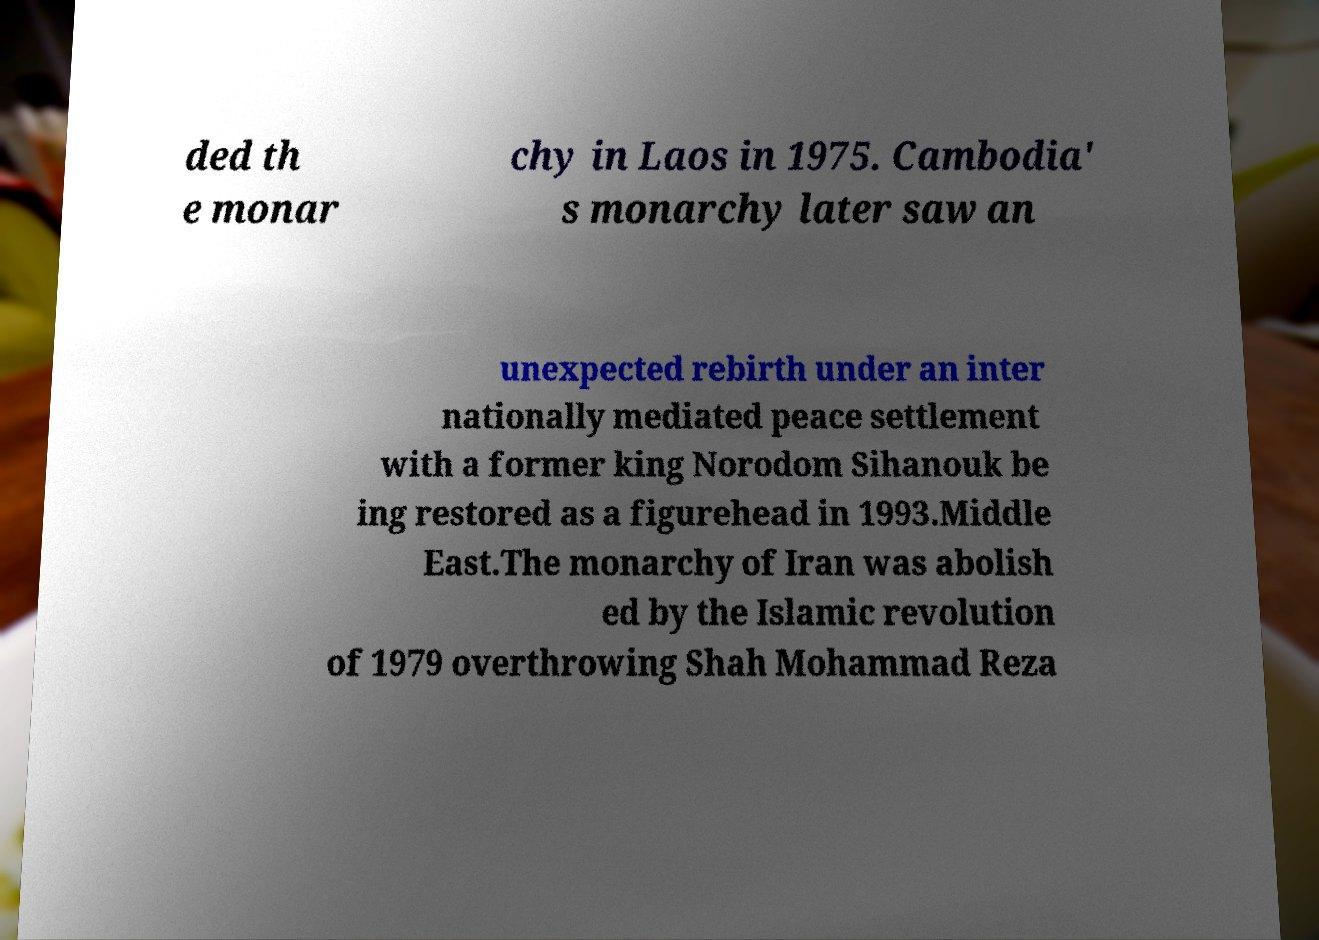I need the written content from this picture converted into text. Can you do that? ded th e monar chy in Laos in 1975. Cambodia' s monarchy later saw an unexpected rebirth under an inter nationally mediated peace settlement with a former king Norodom Sihanouk be ing restored as a figurehead in 1993.Middle East.The monarchy of Iran was abolish ed by the Islamic revolution of 1979 overthrowing Shah Mohammad Reza 